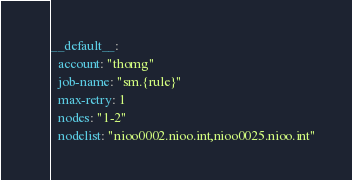Convert code to text. <code><loc_0><loc_0><loc_500><loc_500><_YAML_>__default__:
  account: "thomg"
  job-name: "sm.{rule}"
  max-retry: 1
  nodes: "1-2"
  nodelist: "nioo0002.nioo.int,nioo0025.nioo.int"
</code> 